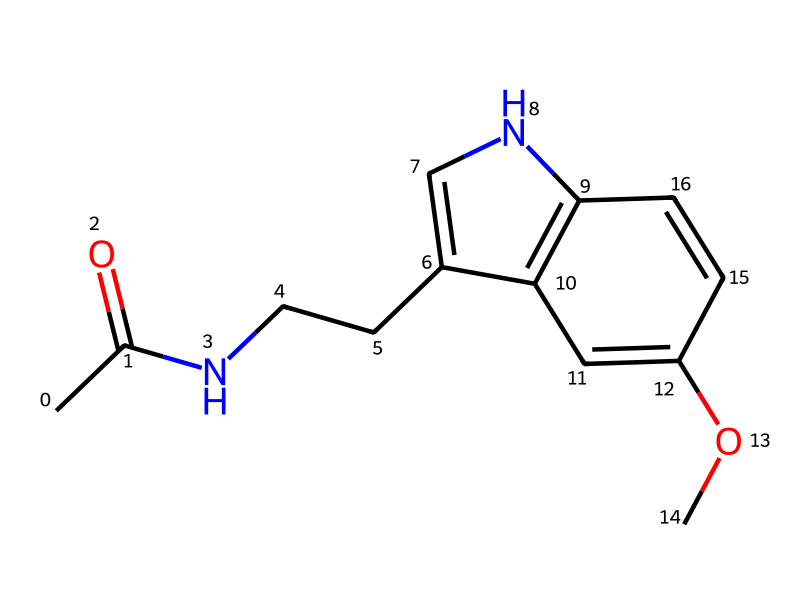What is the main functional group in this chemical? The presence of the carbonyl group (C=O) connected to a nitrogen highlights the amide functional group in the structure. This is represented by the section "CC(=O)N".
Answer: amide How many carbon atoms are in the molecule? Counting each "C" in the SMILES string, there are a total of 10 carbon atoms present in the entire structure.
Answer: 10 What type of molecule is this based on its structure? The presence of both nitrogen and carbon in a specific arrangement suggests that this is an indole derivative, which is a common type of neurotransmitter or hormone.
Answer: indole derivative Does this chemical have aromatic rings? Yes, the part of the structure where "c" (lowercase) is present indicates the aromatic carbon atoms; thus, they contribute to aromaticity in the molecule.
Answer: yes What is the total number of nitrogen atoms in the compound? Looking through the SMILES string, the character "N" appears twice, indicating that there are two nitrogen atoms in this molecule.
Answer: 2 